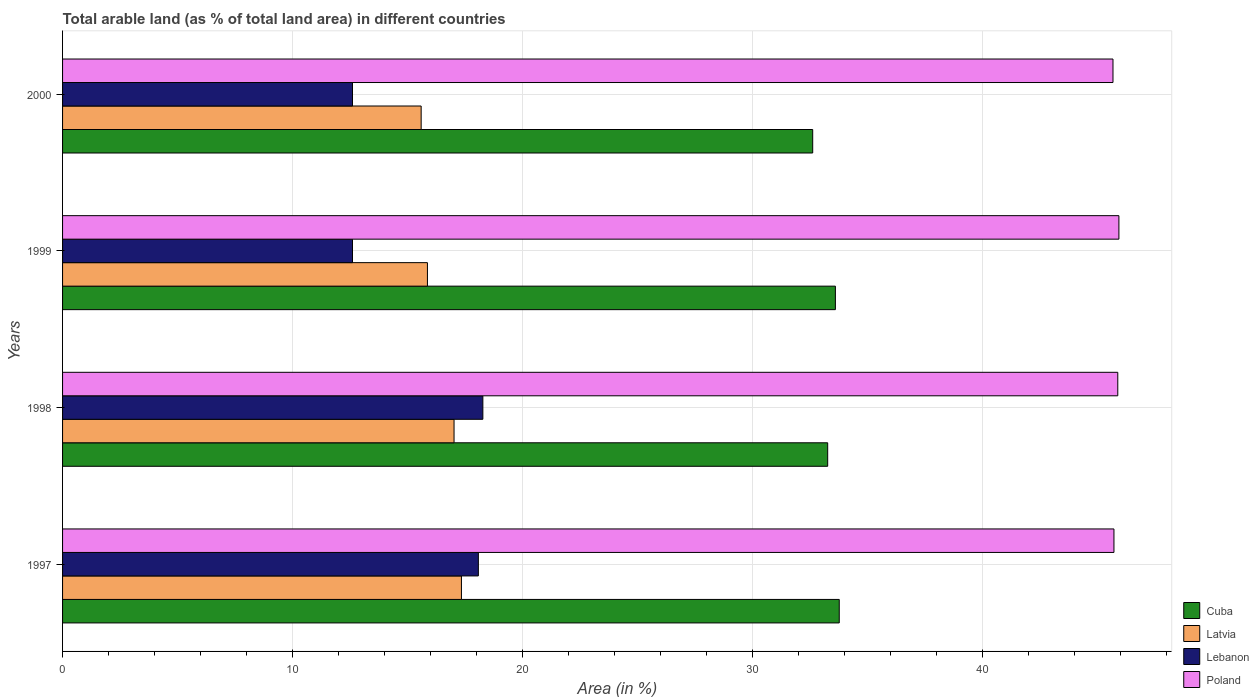How many groups of bars are there?
Your answer should be compact. 4. Are the number of bars per tick equal to the number of legend labels?
Keep it short and to the point. Yes. In how many cases, is the number of bars for a given year not equal to the number of legend labels?
Provide a short and direct response. 0. What is the percentage of arable land in Poland in 1997?
Give a very brief answer. 45.73. Across all years, what is the maximum percentage of arable land in Lebanon?
Provide a succinct answer. 18.28. Across all years, what is the minimum percentage of arable land in Lebanon?
Provide a short and direct response. 12.61. What is the total percentage of arable land in Lebanon in the graph?
Your answer should be compact. 61.58. What is the difference between the percentage of arable land in Poland in 1998 and that in 1999?
Offer a very short reply. -0.05. What is the difference between the percentage of arable land in Latvia in 1998 and the percentage of arable land in Lebanon in 1999?
Offer a very short reply. 4.42. What is the average percentage of arable land in Cuba per year?
Provide a short and direct response. 33.32. In the year 1998, what is the difference between the percentage of arable land in Poland and percentage of arable land in Cuba?
Provide a short and direct response. 12.62. In how many years, is the percentage of arable land in Lebanon greater than 14 %?
Your response must be concise. 2. What is the ratio of the percentage of arable land in Poland in 1998 to that in 2000?
Your response must be concise. 1. Is the percentage of arable land in Latvia in 1998 less than that in 1999?
Your response must be concise. No. What is the difference between the highest and the second highest percentage of arable land in Poland?
Make the answer very short. 0.05. What is the difference between the highest and the lowest percentage of arable land in Lebanon?
Make the answer very short. 5.67. In how many years, is the percentage of arable land in Lebanon greater than the average percentage of arable land in Lebanon taken over all years?
Make the answer very short. 2. Is the sum of the percentage of arable land in Poland in 1997 and 1998 greater than the maximum percentage of arable land in Latvia across all years?
Make the answer very short. Yes. What does the 2nd bar from the top in 2000 represents?
Your answer should be compact. Lebanon. What does the 1st bar from the bottom in 1998 represents?
Offer a very short reply. Cuba. Is it the case that in every year, the sum of the percentage of arable land in Lebanon and percentage of arable land in Cuba is greater than the percentage of arable land in Latvia?
Offer a very short reply. Yes. Are all the bars in the graph horizontal?
Your answer should be compact. Yes. How many years are there in the graph?
Keep it short and to the point. 4. What is the difference between two consecutive major ticks on the X-axis?
Offer a terse response. 10. How many legend labels are there?
Offer a terse response. 4. How are the legend labels stacked?
Ensure brevity in your answer.  Vertical. What is the title of the graph?
Provide a succinct answer. Total arable land (as % of total land area) in different countries. What is the label or title of the X-axis?
Offer a terse response. Area (in %). What is the label or title of the Y-axis?
Give a very brief answer. Years. What is the Area (in %) of Cuba in 1997?
Offer a very short reply. 33.78. What is the Area (in %) in Latvia in 1997?
Offer a very short reply. 17.35. What is the Area (in %) of Lebanon in 1997?
Ensure brevity in your answer.  18.08. What is the Area (in %) of Poland in 1997?
Your response must be concise. 45.73. What is the Area (in %) of Cuba in 1998?
Offer a terse response. 33.28. What is the Area (in %) in Latvia in 1998?
Offer a very short reply. 17.03. What is the Area (in %) of Lebanon in 1998?
Give a very brief answer. 18.28. What is the Area (in %) in Poland in 1998?
Provide a short and direct response. 45.89. What is the Area (in %) of Cuba in 1999?
Provide a succinct answer. 33.61. What is the Area (in %) of Latvia in 1999?
Make the answer very short. 15.87. What is the Area (in %) in Lebanon in 1999?
Offer a terse response. 12.61. What is the Area (in %) in Poland in 1999?
Provide a short and direct response. 45.94. What is the Area (in %) in Cuba in 2000?
Your answer should be compact. 32.63. What is the Area (in %) in Latvia in 2000?
Provide a succinct answer. 15.6. What is the Area (in %) in Lebanon in 2000?
Provide a succinct answer. 12.61. What is the Area (in %) in Poland in 2000?
Ensure brevity in your answer.  45.69. Across all years, what is the maximum Area (in %) in Cuba?
Give a very brief answer. 33.78. Across all years, what is the maximum Area (in %) in Latvia?
Your answer should be compact. 17.35. Across all years, what is the maximum Area (in %) of Lebanon?
Your answer should be very brief. 18.28. Across all years, what is the maximum Area (in %) in Poland?
Your answer should be compact. 45.94. Across all years, what is the minimum Area (in %) of Cuba?
Give a very brief answer. 32.63. Across all years, what is the minimum Area (in %) in Latvia?
Make the answer very short. 15.6. Across all years, what is the minimum Area (in %) in Lebanon?
Provide a succinct answer. 12.61. Across all years, what is the minimum Area (in %) of Poland?
Provide a short and direct response. 45.69. What is the total Area (in %) of Cuba in the graph?
Provide a short and direct response. 133.3. What is the total Area (in %) of Latvia in the graph?
Your answer should be compact. 65.84. What is the total Area (in %) of Lebanon in the graph?
Your answer should be compact. 61.58. What is the total Area (in %) of Poland in the graph?
Offer a terse response. 183.25. What is the difference between the Area (in %) in Cuba in 1997 and that in 1998?
Make the answer very short. 0.5. What is the difference between the Area (in %) in Latvia in 1997 and that in 1998?
Your response must be concise. 0.32. What is the difference between the Area (in %) in Lebanon in 1997 and that in 1998?
Your answer should be compact. -0.2. What is the difference between the Area (in %) in Poland in 1997 and that in 1998?
Make the answer very short. -0.17. What is the difference between the Area (in %) in Cuba in 1997 and that in 1999?
Your response must be concise. 0.17. What is the difference between the Area (in %) in Latvia in 1997 and that in 1999?
Provide a succinct answer. 1.48. What is the difference between the Area (in %) of Lebanon in 1997 and that in 1999?
Keep it short and to the point. 5.47. What is the difference between the Area (in %) in Poland in 1997 and that in 1999?
Ensure brevity in your answer.  -0.22. What is the difference between the Area (in %) of Cuba in 1997 and that in 2000?
Ensure brevity in your answer.  1.15. What is the difference between the Area (in %) of Latvia in 1997 and that in 2000?
Make the answer very short. 1.75. What is the difference between the Area (in %) in Lebanon in 1997 and that in 2000?
Your answer should be compact. 5.47. What is the difference between the Area (in %) in Poland in 1997 and that in 2000?
Your answer should be very brief. 0.04. What is the difference between the Area (in %) of Cuba in 1998 and that in 1999?
Give a very brief answer. -0.34. What is the difference between the Area (in %) in Latvia in 1998 and that in 1999?
Provide a succinct answer. 1.16. What is the difference between the Area (in %) in Lebanon in 1998 and that in 1999?
Make the answer very short. 5.67. What is the difference between the Area (in %) of Poland in 1998 and that in 1999?
Offer a very short reply. -0.05. What is the difference between the Area (in %) in Cuba in 1998 and that in 2000?
Offer a very short reply. 0.65. What is the difference between the Area (in %) in Latvia in 1998 and that in 2000?
Your answer should be very brief. 1.43. What is the difference between the Area (in %) of Lebanon in 1998 and that in 2000?
Your answer should be very brief. 5.67. What is the difference between the Area (in %) of Poland in 1998 and that in 2000?
Provide a succinct answer. 0.21. What is the difference between the Area (in %) in Cuba in 1999 and that in 2000?
Offer a very short reply. 0.99. What is the difference between the Area (in %) in Latvia in 1999 and that in 2000?
Provide a succinct answer. 0.27. What is the difference between the Area (in %) of Poland in 1999 and that in 2000?
Your answer should be very brief. 0.26. What is the difference between the Area (in %) in Cuba in 1997 and the Area (in %) in Latvia in 1998?
Ensure brevity in your answer.  16.75. What is the difference between the Area (in %) of Cuba in 1997 and the Area (in %) of Lebanon in 1998?
Offer a terse response. 15.5. What is the difference between the Area (in %) of Cuba in 1997 and the Area (in %) of Poland in 1998?
Your response must be concise. -12.11. What is the difference between the Area (in %) in Latvia in 1997 and the Area (in %) in Lebanon in 1998?
Your answer should be compact. -0.93. What is the difference between the Area (in %) in Latvia in 1997 and the Area (in %) in Poland in 1998?
Ensure brevity in your answer.  -28.55. What is the difference between the Area (in %) of Lebanon in 1997 and the Area (in %) of Poland in 1998?
Provide a succinct answer. -27.81. What is the difference between the Area (in %) in Cuba in 1997 and the Area (in %) in Latvia in 1999?
Make the answer very short. 17.91. What is the difference between the Area (in %) in Cuba in 1997 and the Area (in %) in Lebanon in 1999?
Offer a terse response. 21.17. What is the difference between the Area (in %) of Cuba in 1997 and the Area (in %) of Poland in 1999?
Your answer should be compact. -12.16. What is the difference between the Area (in %) of Latvia in 1997 and the Area (in %) of Lebanon in 1999?
Your answer should be compact. 4.74. What is the difference between the Area (in %) of Latvia in 1997 and the Area (in %) of Poland in 1999?
Give a very brief answer. -28.59. What is the difference between the Area (in %) in Lebanon in 1997 and the Area (in %) in Poland in 1999?
Offer a terse response. -27.86. What is the difference between the Area (in %) of Cuba in 1997 and the Area (in %) of Latvia in 2000?
Ensure brevity in your answer.  18.18. What is the difference between the Area (in %) in Cuba in 1997 and the Area (in %) in Lebanon in 2000?
Make the answer very short. 21.17. What is the difference between the Area (in %) of Cuba in 1997 and the Area (in %) of Poland in 2000?
Offer a terse response. -11.91. What is the difference between the Area (in %) in Latvia in 1997 and the Area (in %) in Lebanon in 2000?
Your answer should be very brief. 4.74. What is the difference between the Area (in %) of Latvia in 1997 and the Area (in %) of Poland in 2000?
Provide a short and direct response. -28.34. What is the difference between the Area (in %) in Lebanon in 1997 and the Area (in %) in Poland in 2000?
Make the answer very short. -27.6. What is the difference between the Area (in %) in Cuba in 1998 and the Area (in %) in Latvia in 1999?
Provide a short and direct response. 17.41. What is the difference between the Area (in %) in Cuba in 1998 and the Area (in %) in Lebanon in 1999?
Make the answer very short. 20.67. What is the difference between the Area (in %) in Cuba in 1998 and the Area (in %) in Poland in 1999?
Give a very brief answer. -12.67. What is the difference between the Area (in %) of Latvia in 1998 and the Area (in %) of Lebanon in 1999?
Your answer should be very brief. 4.42. What is the difference between the Area (in %) of Latvia in 1998 and the Area (in %) of Poland in 1999?
Offer a terse response. -28.92. What is the difference between the Area (in %) of Lebanon in 1998 and the Area (in %) of Poland in 1999?
Offer a very short reply. -27.66. What is the difference between the Area (in %) of Cuba in 1998 and the Area (in %) of Latvia in 2000?
Provide a short and direct response. 17.68. What is the difference between the Area (in %) of Cuba in 1998 and the Area (in %) of Lebanon in 2000?
Provide a succinct answer. 20.67. What is the difference between the Area (in %) in Cuba in 1998 and the Area (in %) in Poland in 2000?
Offer a very short reply. -12.41. What is the difference between the Area (in %) of Latvia in 1998 and the Area (in %) of Lebanon in 2000?
Provide a succinct answer. 4.42. What is the difference between the Area (in %) of Latvia in 1998 and the Area (in %) of Poland in 2000?
Your answer should be compact. -28.66. What is the difference between the Area (in %) in Lebanon in 1998 and the Area (in %) in Poland in 2000?
Make the answer very short. -27.41. What is the difference between the Area (in %) of Cuba in 1999 and the Area (in %) of Latvia in 2000?
Provide a succinct answer. 18.02. What is the difference between the Area (in %) of Cuba in 1999 and the Area (in %) of Lebanon in 2000?
Give a very brief answer. 21. What is the difference between the Area (in %) in Cuba in 1999 and the Area (in %) in Poland in 2000?
Your response must be concise. -12.07. What is the difference between the Area (in %) in Latvia in 1999 and the Area (in %) in Lebanon in 2000?
Provide a short and direct response. 3.26. What is the difference between the Area (in %) in Latvia in 1999 and the Area (in %) in Poland in 2000?
Your answer should be very brief. -29.82. What is the difference between the Area (in %) in Lebanon in 1999 and the Area (in %) in Poland in 2000?
Your answer should be compact. -33.08. What is the average Area (in %) of Cuba per year?
Offer a very short reply. 33.32. What is the average Area (in %) in Latvia per year?
Your answer should be compact. 16.46. What is the average Area (in %) in Lebanon per year?
Give a very brief answer. 15.4. What is the average Area (in %) in Poland per year?
Your answer should be compact. 45.81. In the year 1997, what is the difference between the Area (in %) in Cuba and Area (in %) in Latvia?
Your answer should be compact. 16.43. In the year 1997, what is the difference between the Area (in %) of Cuba and Area (in %) of Lebanon?
Ensure brevity in your answer.  15.7. In the year 1997, what is the difference between the Area (in %) of Cuba and Area (in %) of Poland?
Keep it short and to the point. -11.95. In the year 1997, what is the difference between the Area (in %) in Latvia and Area (in %) in Lebanon?
Offer a very short reply. -0.74. In the year 1997, what is the difference between the Area (in %) of Latvia and Area (in %) of Poland?
Offer a terse response. -28.38. In the year 1997, what is the difference between the Area (in %) in Lebanon and Area (in %) in Poland?
Make the answer very short. -27.64. In the year 1998, what is the difference between the Area (in %) of Cuba and Area (in %) of Latvia?
Keep it short and to the point. 16.25. In the year 1998, what is the difference between the Area (in %) of Cuba and Area (in %) of Lebanon?
Your answer should be compact. 15. In the year 1998, what is the difference between the Area (in %) of Cuba and Area (in %) of Poland?
Ensure brevity in your answer.  -12.62. In the year 1998, what is the difference between the Area (in %) of Latvia and Area (in %) of Lebanon?
Make the answer very short. -1.25. In the year 1998, what is the difference between the Area (in %) of Latvia and Area (in %) of Poland?
Keep it short and to the point. -28.87. In the year 1998, what is the difference between the Area (in %) in Lebanon and Area (in %) in Poland?
Ensure brevity in your answer.  -27.61. In the year 1999, what is the difference between the Area (in %) of Cuba and Area (in %) of Latvia?
Provide a short and direct response. 17.74. In the year 1999, what is the difference between the Area (in %) in Cuba and Area (in %) in Lebanon?
Ensure brevity in your answer.  21. In the year 1999, what is the difference between the Area (in %) of Cuba and Area (in %) of Poland?
Your response must be concise. -12.33. In the year 1999, what is the difference between the Area (in %) of Latvia and Area (in %) of Lebanon?
Offer a very short reply. 3.26. In the year 1999, what is the difference between the Area (in %) in Latvia and Area (in %) in Poland?
Give a very brief answer. -30.07. In the year 1999, what is the difference between the Area (in %) of Lebanon and Area (in %) of Poland?
Provide a succinct answer. -33.33. In the year 2000, what is the difference between the Area (in %) in Cuba and Area (in %) in Latvia?
Give a very brief answer. 17.03. In the year 2000, what is the difference between the Area (in %) in Cuba and Area (in %) in Lebanon?
Keep it short and to the point. 20.02. In the year 2000, what is the difference between the Area (in %) of Cuba and Area (in %) of Poland?
Offer a very short reply. -13.06. In the year 2000, what is the difference between the Area (in %) in Latvia and Area (in %) in Lebanon?
Ensure brevity in your answer.  2.99. In the year 2000, what is the difference between the Area (in %) in Latvia and Area (in %) in Poland?
Give a very brief answer. -30.09. In the year 2000, what is the difference between the Area (in %) of Lebanon and Area (in %) of Poland?
Your response must be concise. -33.08. What is the ratio of the Area (in %) of Cuba in 1997 to that in 1998?
Your response must be concise. 1.02. What is the ratio of the Area (in %) in Latvia in 1997 to that in 1998?
Give a very brief answer. 1.02. What is the ratio of the Area (in %) of Lebanon in 1997 to that in 1998?
Provide a succinct answer. 0.99. What is the ratio of the Area (in %) in Poland in 1997 to that in 1998?
Your answer should be compact. 1. What is the ratio of the Area (in %) in Cuba in 1997 to that in 1999?
Offer a very short reply. 1. What is the ratio of the Area (in %) in Latvia in 1997 to that in 1999?
Provide a succinct answer. 1.09. What is the ratio of the Area (in %) in Lebanon in 1997 to that in 1999?
Keep it short and to the point. 1.43. What is the ratio of the Area (in %) of Poland in 1997 to that in 1999?
Offer a terse response. 1. What is the ratio of the Area (in %) of Cuba in 1997 to that in 2000?
Provide a succinct answer. 1.04. What is the ratio of the Area (in %) in Latvia in 1997 to that in 2000?
Your answer should be very brief. 1.11. What is the ratio of the Area (in %) of Lebanon in 1997 to that in 2000?
Give a very brief answer. 1.43. What is the ratio of the Area (in %) in Poland in 1997 to that in 2000?
Your answer should be compact. 1. What is the ratio of the Area (in %) in Latvia in 1998 to that in 1999?
Provide a short and direct response. 1.07. What is the ratio of the Area (in %) in Lebanon in 1998 to that in 1999?
Offer a very short reply. 1.45. What is the ratio of the Area (in %) in Latvia in 1998 to that in 2000?
Ensure brevity in your answer.  1.09. What is the ratio of the Area (in %) in Lebanon in 1998 to that in 2000?
Keep it short and to the point. 1.45. What is the ratio of the Area (in %) in Cuba in 1999 to that in 2000?
Offer a very short reply. 1.03. What is the ratio of the Area (in %) of Latvia in 1999 to that in 2000?
Offer a terse response. 1.02. What is the ratio of the Area (in %) in Lebanon in 1999 to that in 2000?
Offer a terse response. 1. What is the ratio of the Area (in %) in Poland in 1999 to that in 2000?
Provide a succinct answer. 1.01. What is the difference between the highest and the second highest Area (in %) of Cuba?
Offer a very short reply. 0.17. What is the difference between the highest and the second highest Area (in %) of Latvia?
Offer a very short reply. 0.32. What is the difference between the highest and the second highest Area (in %) in Lebanon?
Your answer should be compact. 0.2. What is the difference between the highest and the second highest Area (in %) in Poland?
Provide a succinct answer. 0.05. What is the difference between the highest and the lowest Area (in %) in Cuba?
Give a very brief answer. 1.15. What is the difference between the highest and the lowest Area (in %) of Latvia?
Your response must be concise. 1.75. What is the difference between the highest and the lowest Area (in %) in Lebanon?
Offer a very short reply. 5.67. What is the difference between the highest and the lowest Area (in %) in Poland?
Offer a terse response. 0.26. 